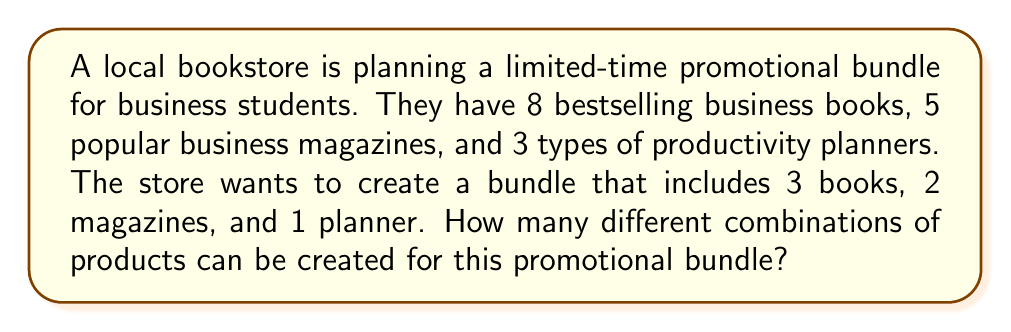What is the answer to this math problem? Let's approach this step-by-step using the combination formula:

1) For the books:
   We need to choose 3 books out of 8. This can be represented as $\binom{8}{3}$.
   $$\binom{8}{3} = \frac{8!}{3!(8-3)!} = \frac{8!}{3!5!} = 56$$

2) For the magazines:
   We need to choose 2 magazines out of 5. This is $\binom{5}{2}$.
   $$\binom{5}{2} = \frac{5!}{2!(5-2)!} = \frac{5!}{2!3!} = 10$$

3) For the planners:
   We need to choose 1 planner out of 3. This is $\binom{3}{1}$.
   $$\binom{3}{1} = \frac{3!}{1!(3-1)!} = \frac{3!}{1!2!} = 3$$

4) Now, according to the Multiplication Principle, if we have 56 ways to choose the books, 10 ways to choose the magazines, and 3 ways to choose the planner, the total number of possible combinations is:

   $$56 \times 10 \times 3 = 1,680$$

Therefore, the bookstore can create 1,680 different combinations for their promotional bundle.
Answer: 1,680 different combinations 